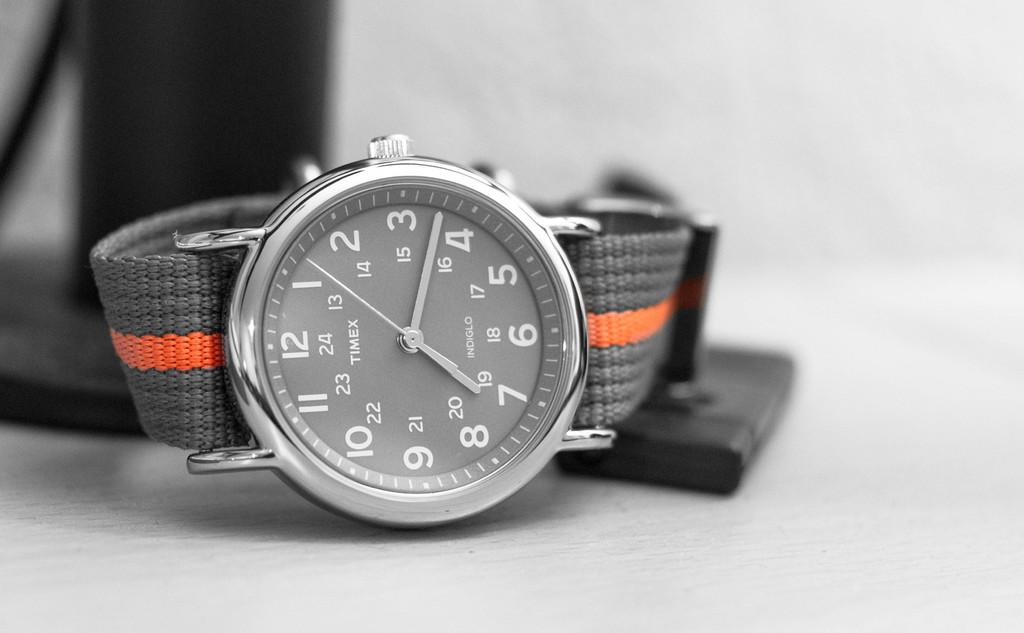<image>
Give a short and clear explanation of the subsequent image. A gray watch from Timex has an orange stripe on the band. 